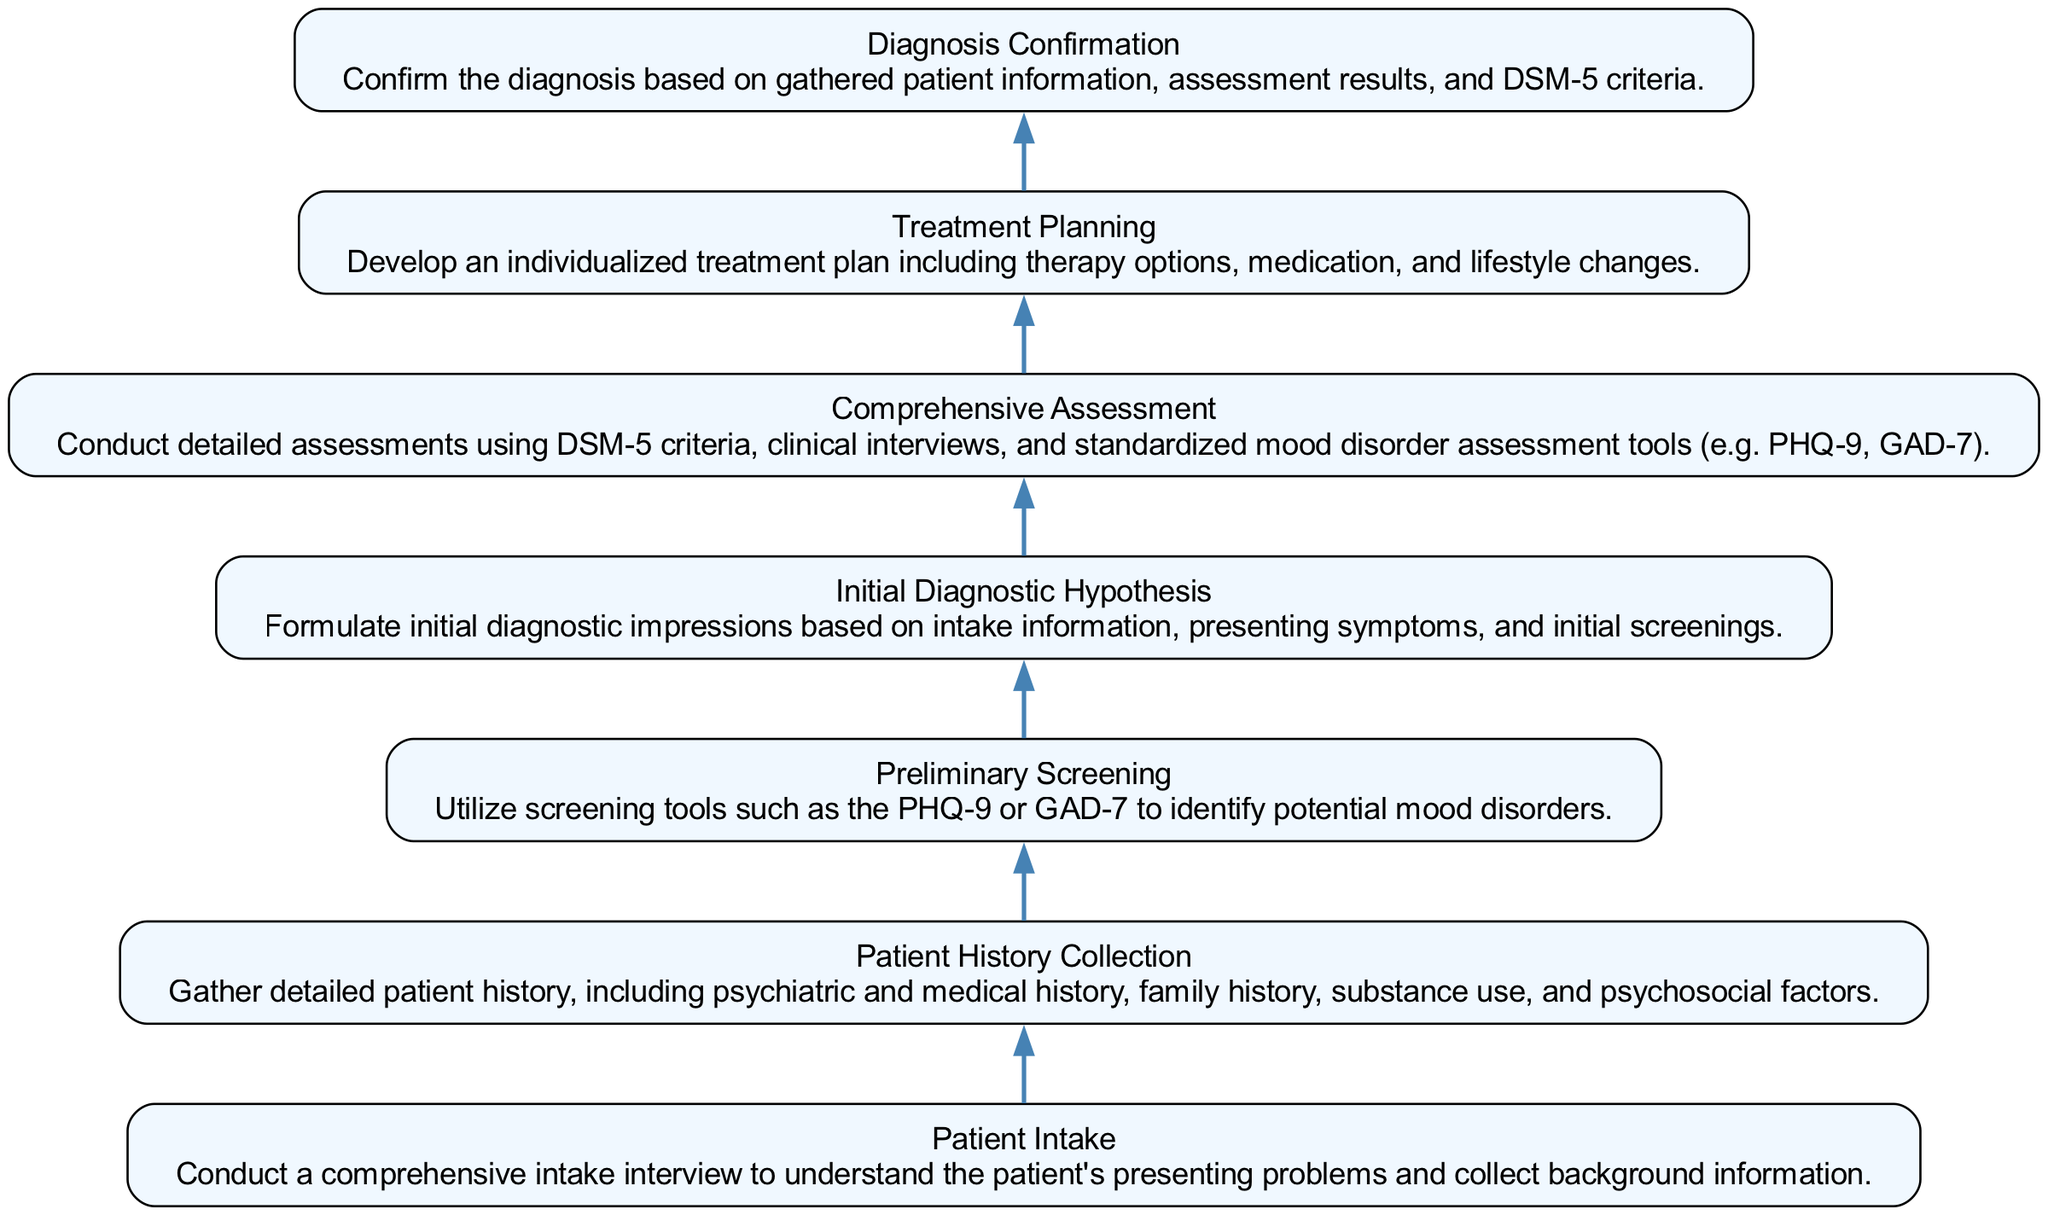What is the first step in the process for evaluating mood disorders? The first step in the process is 'Patient Intake', which involves conducting a comprehensive intake interview to understand the patient's presenting problems.
Answer: Patient Intake How many total steps are in the evaluation process? The diagram contains a total of 7 steps, listed from Patient Intake to Diagnosis Confirmation.
Answer: 7 What is the connection between 'Preliminary Screening' and 'Initial Diagnostic Hypothesis'? The connection is that 'Preliminary Screening' is conducted first to identify potential mood disorders, which then leads to forming an 'Initial Diagnostic Hypothesis'.
Answer: Initial Diagnostic Hypothesis What is the last step of the process? The last step of the process is 'Diagnosis Confirmation', where the diagnosis is confirmed based on gathered information and assessment results.
Answer: Diagnosis Confirmation Which two steps directly follow 'Comprehensive Assessment'? The two steps that directly follow 'Comprehensive Assessment' are 'Initial Diagnostic Hypothesis' and 'Treatment Planning'.
Answer: Initial Diagnostic Hypothesis, Treatment Planning What type of assessment is used during 'Comprehensive Assessment'? The type of assessment used is 'DSM-5 criteria', along with clinical interviews and standardized mood disorder assessment tools like PHQ-9 and GAD-7.
Answer: DSM-5 criteria Which element includes the gathering of substance use information? The element that includes the gathering of substance use information is 'Patient History Collection'.
Answer: Patient History Collection How does 'Treatment Planning' relate to 'Diagnosis Confirmation'? 'Treatment Planning' follows 'Diagnosis Confirmation', as it develops an individualized approach based on confirmed diagnoses.
Answer: follows 